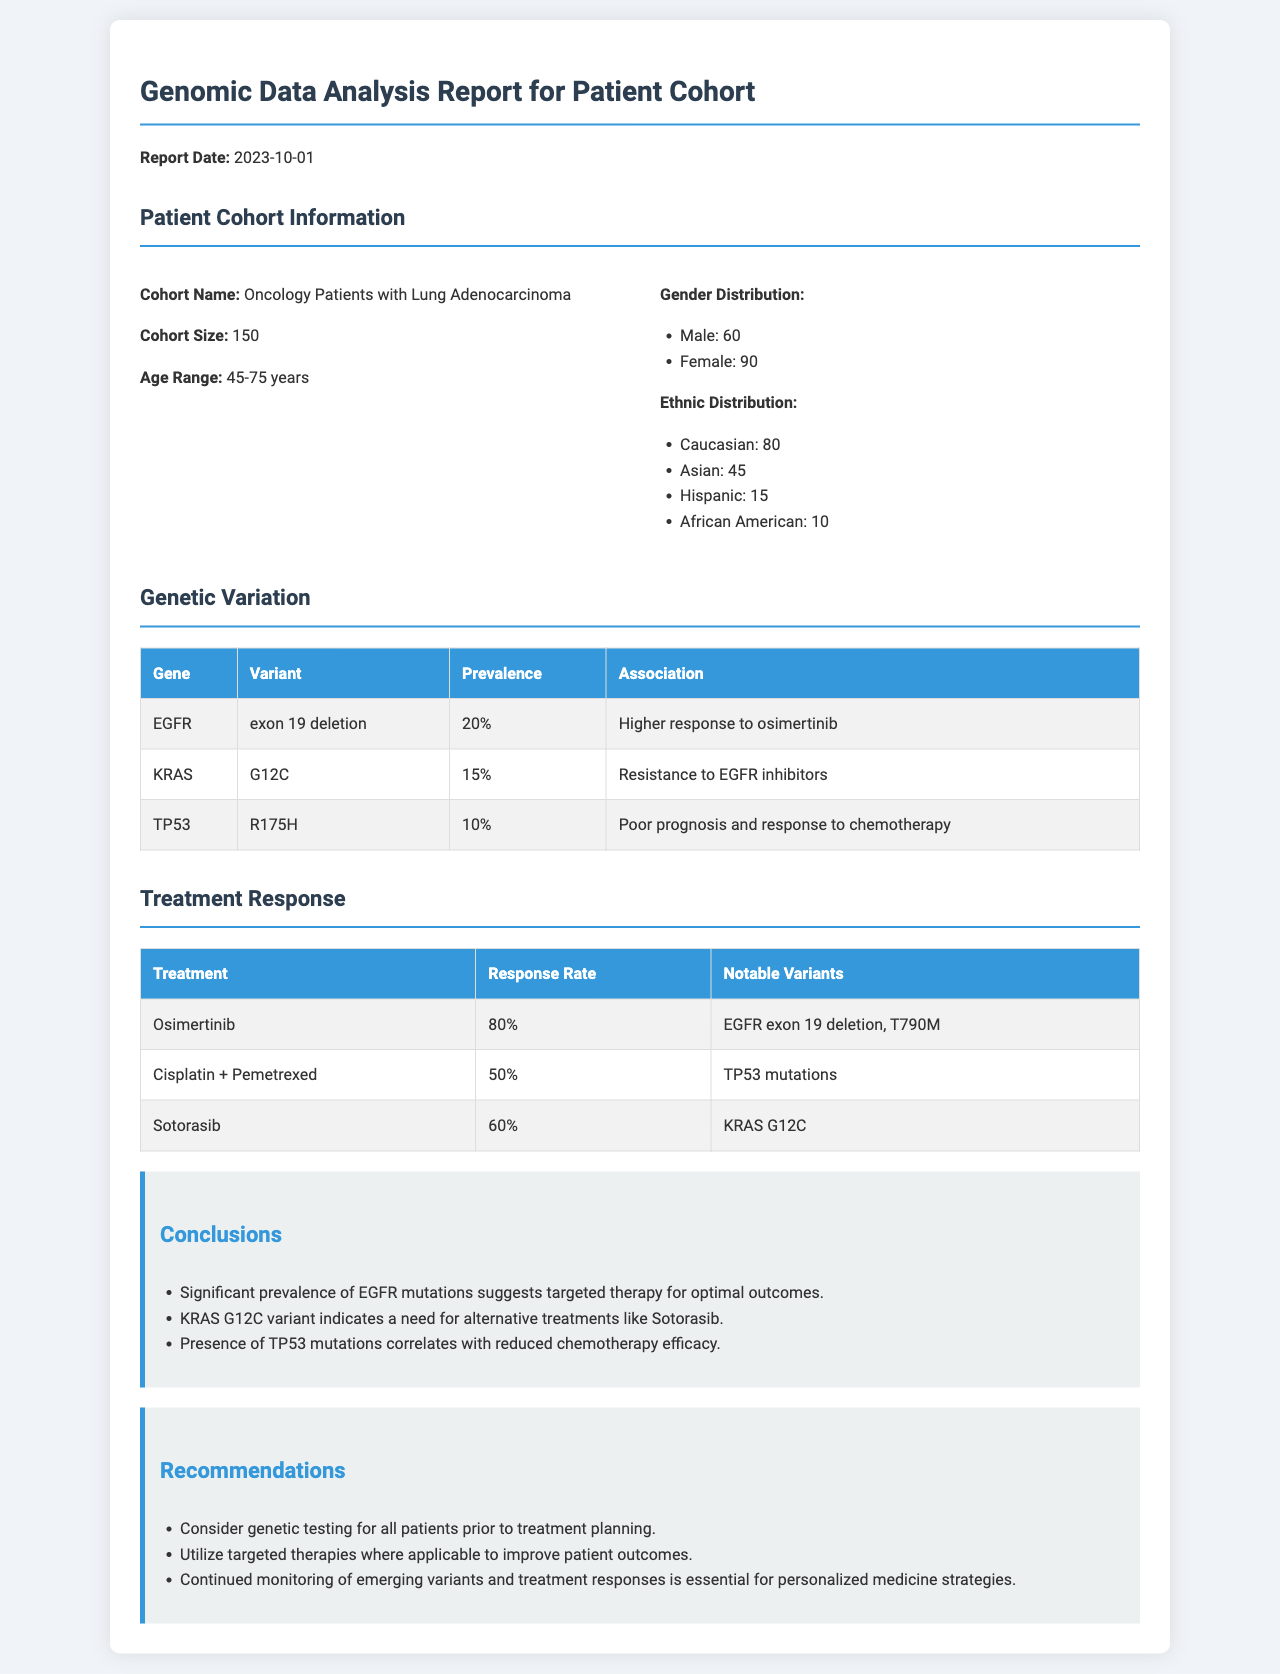What is the cohort name? The cohort name is explicitly mentioned in the document as "Oncology Patients with Lung Adenocarcinoma."
Answer: Oncology Patients with Lung Adenocarcinoma What is the age range of the patient cohort? The age range of the patient cohort is specified as "45-75 years."
Answer: 45-75 years What percentage of patients have the EGFR exon 19 deletion variant? The prevalence of the EGFR exon 19 deletion variant is listed as "20%."
Answer: 20% What is the response rate for Osimertinib? The document states the response rate for Osimertinib as "80%."
Answer: 80% What notable variants are associated with Cisplatin + Pemetrexed treatment? The document mentions "TP53 mutations" as the notable variants for this treatment.
Answer: TP53 mutations Which treatment is associated with a resistance to EGFR inhibitors? The KRAS G12C variant is associated with resistance to EGFR inhibitors, as indicated in the genetic variation section.
Answer: KRAS G12C What recommendation is made regarding genetic testing? The document recommends "Consider genetic testing for all patients prior to treatment planning."
Answer: Consider genetic testing for all patients prior to treatment planning What conclusion suggests a need for alternative treatments? The conclusion regarding the KRAS G12C variant indicates a need for alternative treatments like Sotorasib.
Answer: KRAS G12C variant What is the gender distribution of the cohort? The document provides specific numbers for gender distribution: 60 males and 90 females.
Answer: Male: 60, Female: 90 